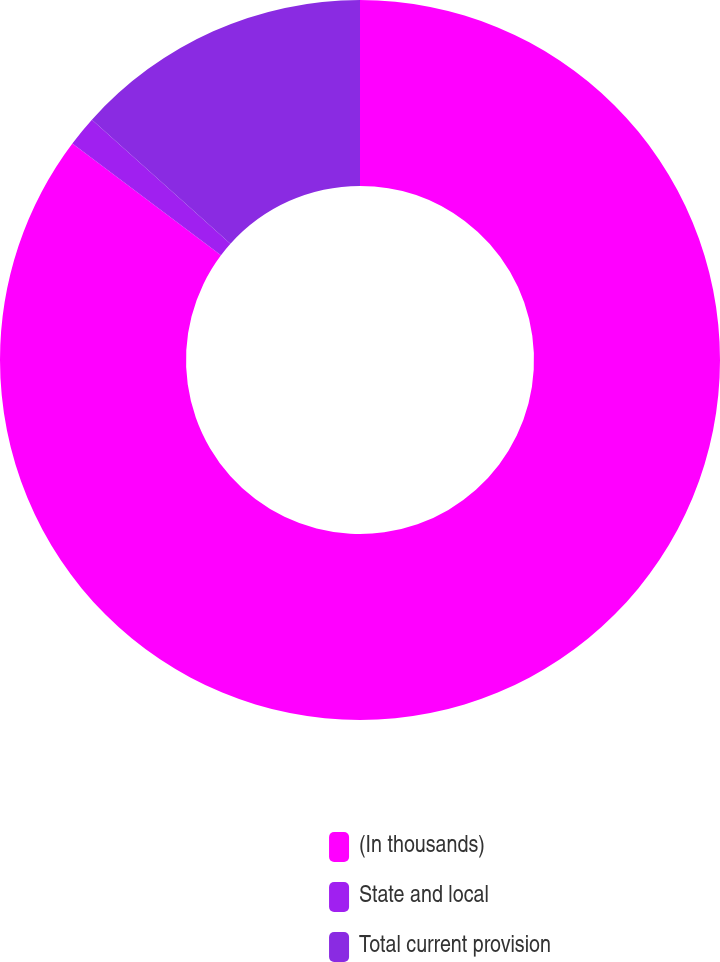<chart> <loc_0><loc_0><loc_500><loc_500><pie_chart><fcel>(In thousands)<fcel>State and local<fcel>Total current provision<nl><fcel>85.27%<fcel>1.36%<fcel>13.37%<nl></chart> 